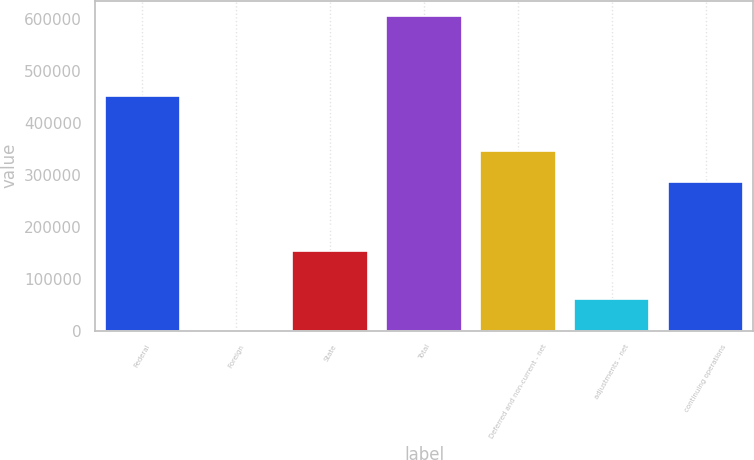Convert chart. <chart><loc_0><loc_0><loc_500><loc_500><bar_chart><fcel>Federal<fcel>Foreign<fcel>State<fcel>Total<fcel>Deferred and non-current - net<fcel>adjustments - net<fcel>continuing operations<nl><fcel>452713<fcel>130<fcel>152711<fcel>605554<fcel>346805<fcel>60672.4<fcel>286263<nl></chart> 